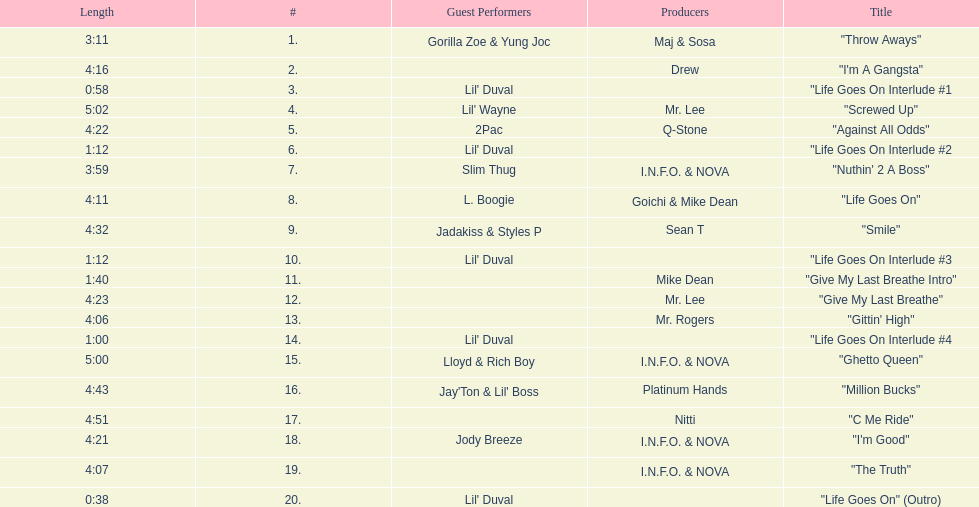Would you mind parsing the complete table? {'header': ['Length', '#', 'Guest Performers', 'Producers', 'Title'], 'rows': [['3:11', '1.', 'Gorilla Zoe & Yung Joc', 'Maj & Sosa', '"Throw Aways"'], ['4:16', '2.', '', 'Drew', '"I\'m A Gangsta"'], ['0:58', '3.', "Lil' Duval", '', '"Life Goes On Interlude #1'], ['5:02', '4.', "Lil' Wayne", 'Mr. Lee', '"Screwed Up"'], ['4:22', '5.', '2Pac', 'Q-Stone', '"Against All Odds"'], ['1:12', '6.', "Lil' Duval", '', '"Life Goes On Interlude #2'], ['3:59', '7.', 'Slim Thug', 'I.N.F.O. & NOVA', '"Nuthin\' 2 A Boss"'], ['4:11', '8.', 'L. Boogie', 'Goichi & Mike Dean', '"Life Goes On"'], ['4:32', '9.', 'Jadakiss & Styles P', 'Sean T', '"Smile"'], ['1:12', '10.', "Lil' Duval", '', '"Life Goes On Interlude #3'], ['1:40', '11.', '', 'Mike Dean', '"Give My Last Breathe Intro"'], ['4:23', '12.', '', 'Mr. Lee', '"Give My Last Breathe"'], ['4:06', '13.', '', 'Mr. Rogers', '"Gittin\' High"'], ['1:00', '14.', "Lil' Duval", '', '"Life Goes On Interlude #4'], ['5:00', '15.', 'Lloyd & Rich Boy', 'I.N.F.O. & NOVA', '"Ghetto Queen"'], ['4:43', '16.', "Jay'Ton & Lil' Boss", 'Platinum Hands', '"Million Bucks"'], ['4:51', '17.', '', 'Nitti', '"C Me Ride"'], ['4:21', '18.', 'Jody Breeze', 'I.N.F.O. & NOVA', '"I\'m Good"'], ['4:07', '19.', '', 'I.N.F.O. & NOVA', '"The Truth"'], ['0:38', '20.', "Lil' Duval", '', '"Life Goes On" (Outro)']]} How many tracks on trae's album "life goes on"? 20. 